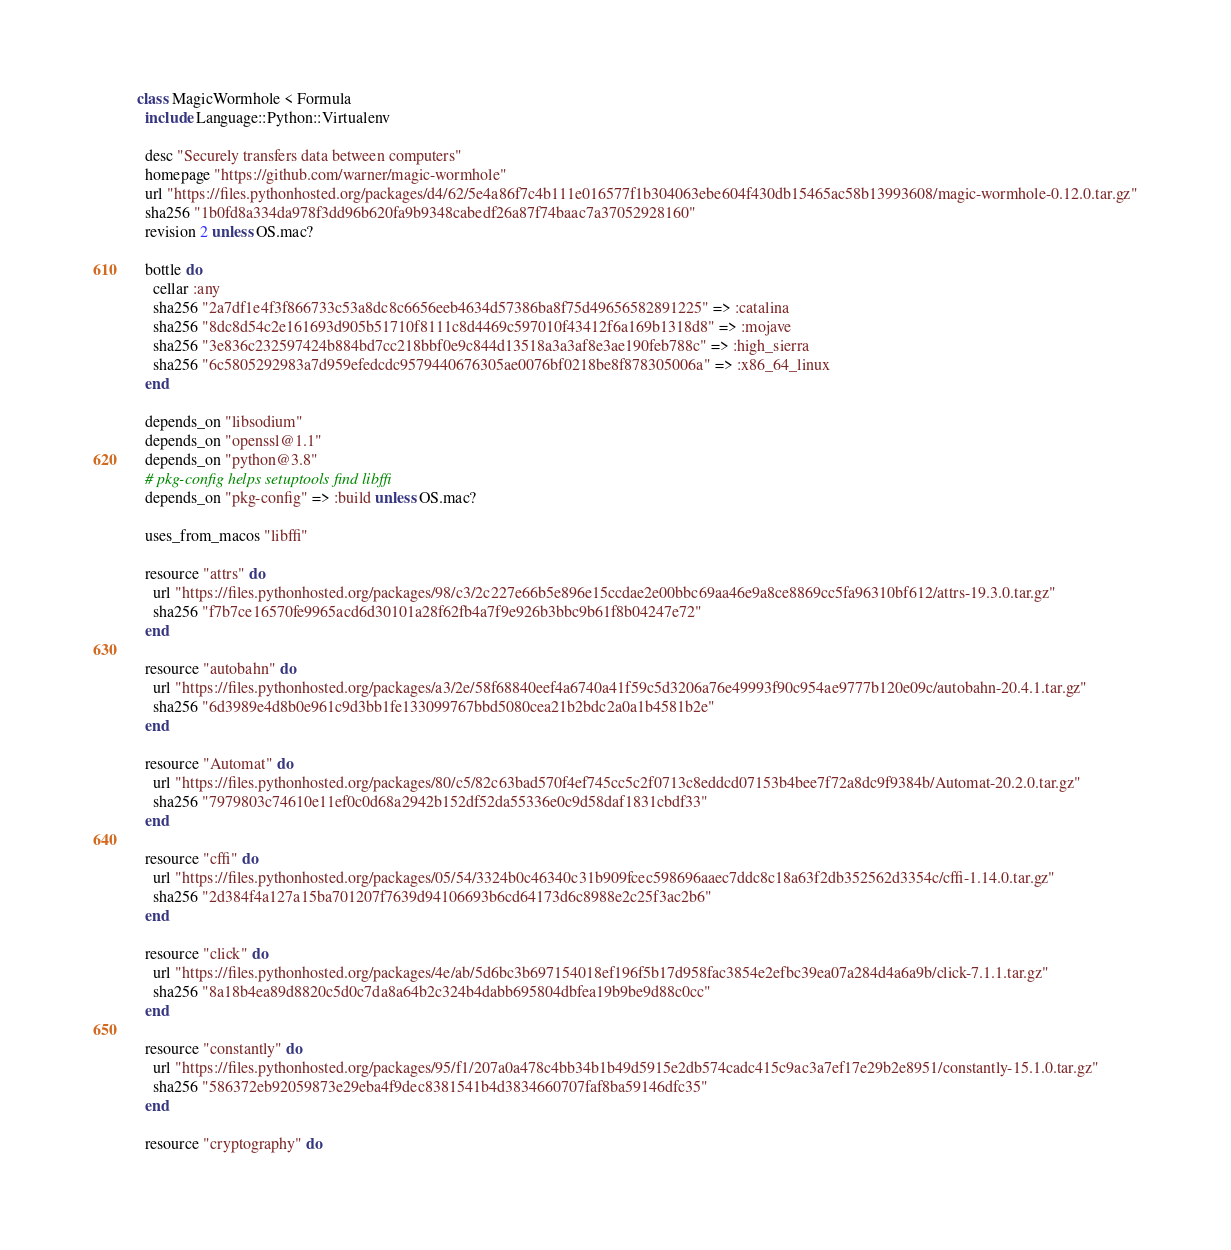Convert code to text. <code><loc_0><loc_0><loc_500><loc_500><_Ruby_>class MagicWormhole < Formula
  include Language::Python::Virtualenv

  desc "Securely transfers data between computers"
  homepage "https://github.com/warner/magic-wormhole"
  url "https://files.pythonhosted.org/packages/d4/62/5e4a86f7c4b111e016577f1b304063ebe604f430db15465ac58b13993608/magic-wormhole-0.12.0.tar.gz"
  sha256 "1b0fd8a334da978f3dd96b620fa9b9348cabedf26a87f74baac7a37052928160"
  revision 2 unless OS.mac?

  bottle do
    cellar :any
    sha256 "2a7df1e4f3f866733c53a8dc8c6656eeb4634d57386ba8f75d49656582891225" => :catalina
    sha256 "8dc8d54c2e161693d905b51710f8111c8d4469c597010f43412f6a169b1318d8" => :mojave
    sha256 "3e836c232597424b884bd7cc218bbf0e9c844d13518a3a3af8e3ae190feb788c" => :high_sierra
    sha256 "6c5805292983a7d959efedcdc9579440676305ae0076bf0218be8f878305006a" => :x86_64_linux
  end

  depends_on "libsodium"
  depends_on "openssl@1.1"
  depends_on "python@3.8"
  # pkg-config helps setuptools find libffi
  depends_on "pkg-config" => :build unless OS.mac?

  uses_from_macos "libffi"

  resource "attrs" do
    url "https://files.pythonhosted.org/packages/98/c3/2c227e66b5e896e15ccdae2e00bbc69aa46e9a8ce8869cc5fa96310bf612/attrs-19.3.0.tar.gz"
    sha256 "f7b7ce16570fe9965acd6d30101a28f62fb4a7f9e926b3bbc9b61f8b04247e72"
  end

  resource "autobahn" do
    url "https://files.pythonhosted.org/packages/a3/2e/58f68840eef4a6740a41f59c5d3206a76e49993f90c954ae9777b120e09c/autobahn-20.4.1.tar.gz"
    sha256 "6d3989e4d8b0e961c9d3bb1fe133099767bbd5080cea21b2bdc2a0a1b4581b2e"
  end

  resource "Automat" do
    url "https://files.pythonhosted.org/packages/80/c5/82c63bad570f4ef745cc5c2f0713c8eddcd07153b4bee7f72a8dc9f9384b/Automat-20.2.0.tar.gz"
    sha256 "7979803c74610e11ef0c0d68a2942b152df52da55336e0c9d58daf1831cbdf33"
  end

  resource "cffi" do
    url "https://files.pythonhosted.org/packages/05/54/3324b0c46340c31b909fcec598696aaec7ddc8c18a63f2db352562d3354c/cffi-1.14.0.tar.gz"
    sha256 "2d384f4a127a15ba701207f7639d94106693b6cd64173d6c8988e2c25f3ac2b6"
  end

  resource "click" do
    url "https://files.pythonhosted.org/packages/4e/ab/5d6bc3b697154018ef196f5b17d958fac3854e2efbc39ea07a284d4a6a9b/click-7.1.1.tar.gz"
    sha256 "8a18b4ea89d8820c5d0c7da8a64b2c324b4dabb695804dbfea19b9be9d88c0cc"
  end

  resource "constantly" do
    url "https://files.pythonhosted.org/packages/95/f1/207a0a478c4bb34b1b49d5915e2db574cadc415c9ac3a7ef17e29b2e8951/constantly-15.1.0.tar.gz"
    sha256 "586372eb92059873e29eba4f9dec8381541b4d3834660707faf8ba59146dfc35"
  end

  resource "cryptography" do</code> 